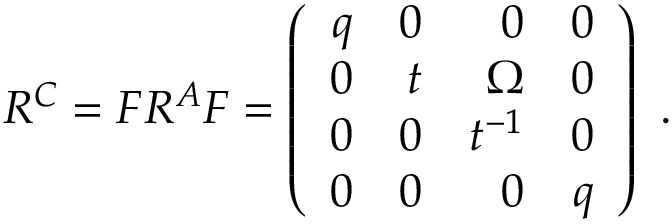<formula> <loc_0><loc_0><loc_500><loc_500>R ^ { C } = F R ^ { A } F = \left ( \begin{array} { r r r r } { q } & { 0 } & { 0 } & { 0 } \\ { 0 } & { t } & { \Omega } & { 0 } \\ { 0 } & { 0 } & { { t ^ { - 1 } } } & { 0 } \\ { 0 } & { 0 } & { 0 } & { q } \end{array} \right ) \ .</formula> 